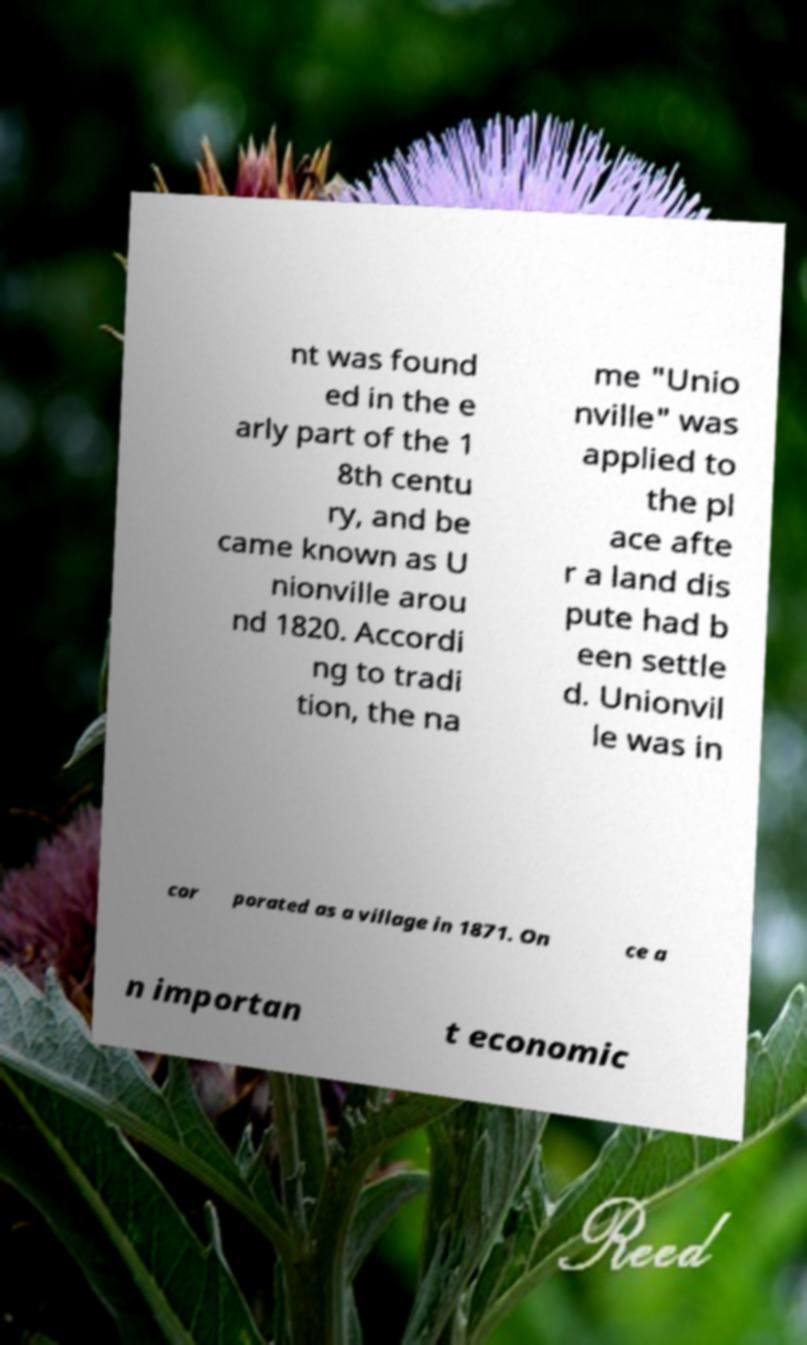What messages or text are displayed in this image? I need them in a readable, typed format. nt was found ed in the e arly part of the 1 8th centu ry, and be came known as U nionville arou nd 1820. Accordi ng to tradi tion, the na me "Unio nville" was applied to the pl ace afte r a land dis pute had b een settle d. Unionvil le was in cor porated as a village in 1871. On ce a n importan t economic 